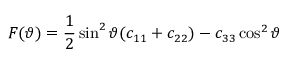Convert formula to latex. <formula><loc_0><loc_0><loc_500><loc_500>F ( \vartheta ) = \frac { 1 } { 2 } \sin ^ { 2 } \vartheta ( c _ { 1 1 } + c _ { 2 2 } ) - c _ { 3 3 } \cos ^ { 2 } \vartheta</formula> 